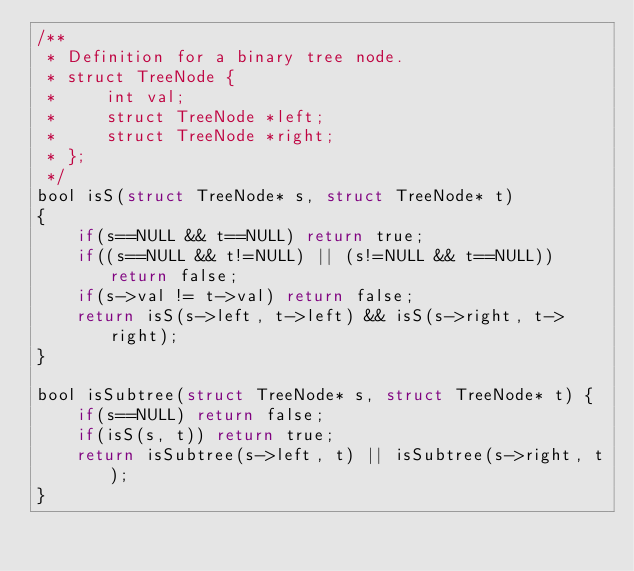Convert code to text. <code><loc_0><loc_0><loc_500><loc_500><_C_>/**
 * Definition for a binary tree node.
 * struct TreeNode {
 *     int val;
 *     struct TreeNode *left;
 *     struct TreeNode *right;
 * };
 */
bool isS(struct TreeNode* s, struct TreeNode* t)
{
    if(s==NULL && t==NULL) return true;
    if((s==NULL && t!=NULL) || (s!=NULL && t==NULL)) return false;
    if(s->val != t->val) return false;
    return isS(s->left, t->left) && isS(s->right, t->right);
}

bool isSubtree(struct TreeNode* s, struct TreeNode* t) {
    if(s==NULL) return false;
    if(isS(s, t)) return true;
    return isSubtree(s->left, t) || isSubtree(s->right, t);
}
</code> 